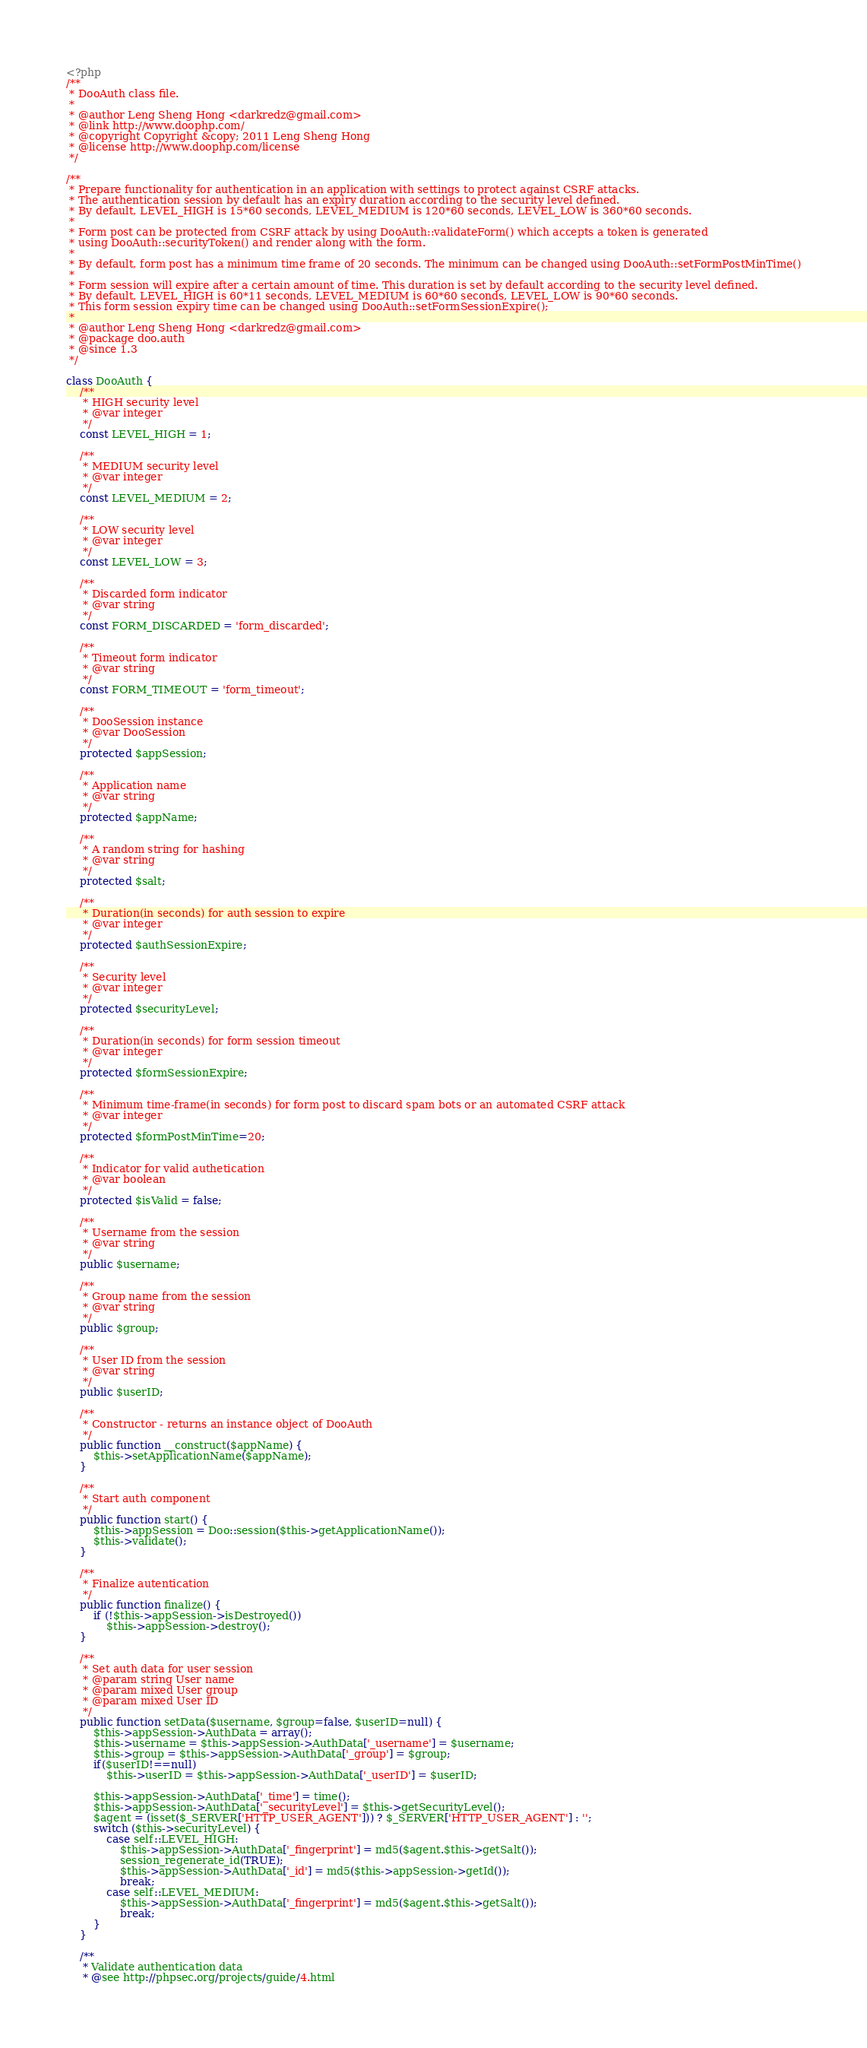Convert code to text. <code><loc_0><loc_0><loc_500><loc_500><_PHP_><?php
/**
 * DooAuth class file.
 *
 * @author Leng Sheng Hong <darkredz@gmail.com>
 * @link http://www.doophp.com/
 * @copyright Copyright &copy; 2011 Leng Sheng Hong
 * @license http://www.doophp.com/license
 */

/**
 * Prepare functionality for authentication in an application with settings to protect against CSRF attacks.
 * The authentication session by default has an expiry duration according to the security level defined.
 * By default, LEVEL_HIGH is 15*60 seconds, LEVEL_MEDIUM is 120*60 seconds, LEVEL_LOW is 360*60 seconds.
 *
 * Form post can be protected from CSRF attack by using DooAuth::validateForm() which accepts a token is generated
 * using DooAuth::securityToken() and render along with the form.
 *
 * By default, form post has a minimum time frame of 20 seconds. The minimum can be changed using DooAuth::setFormPostMinTime()
 *
 * Form session will expire after a certain amount of time. This duration is set by default according to the security level defined.
 * By default, LEVEL_HIGH is 60*11 seconds, LEVEL_MEDIUM is 60*60 seconds, LEVEL_LOW is 90*60 seconds.
 * This form session expiry time can be changed using DooAuth::setFormSessionExpire();
 *
 * @author Leng Sheng Hong <darkredz@gmail.com>
 * @package doo.auth
 * @since 1.3
 */

class DooAuth {
    /**
     * HIGH security level
     * @var integer
     */
    const LEVEL_HIGH = 1;

    /**
     * MEDIUM security level
     * @var integer
     */
    const LEVEL_MEDIUM = 2;

    /**
     * LOW security level
     * @var integer
     */
    const LEVEL_LOW = 3;

    /**
     * Discarded form indicator
     * @var string
     */
    const FORM_DISCARDED = 'form_discarded';

    /**
     * Timeout form indicator
     * @var string
     */
    const FORM_TIMEOUT = 'form_timeout';

    /**
     * DooSession instance
     * @var DooSession
     */
    protected $appSession;

    /**
     * Application name
     * @var string
     */
    protected $appName;

    /**
     * A random string for hashing
     * @var string
     */
    protected $salt;

    /**
     * Duration(in seconds) for auth session to expire
     * @var integer
     */
    protected $authSessionExpire;

    /**
     * Security level
     * @var integer
     */
    protected $securityLevel;

    /**
     * Duration(in seconds) for form session timeout
     * @var integer
     */
    protected $formSessionExpire;

    /**
     * Minimum time-frame(in seconds) for form post to discard spam bots or an automated CSRF attack
     * @var integer
     */
    protected $formPostMinTime=20;

    /**
     * Indicator for valid authetication
     * @var boolean
     */
    protected $isValid = false;

    /**
     * Username from the session
     * @var string
     */
    public $username;

    /**
     * Group name from the session
     * @var string
     */
    public $group;

    /**
     * User ID from the session
     * @var string
     */
    public $userID;

    /**
     * Constructor - returns an instance object of DooAuth
     */
    public function __construct($appName) {
        $this->setApplicationName($appName);
    }

    /**
     * Start auth component
     */
    public function start() {
        $this->appSession = Doo::session($this->getApplicationName());
        $this->validate();
    }

    /**
     * Finalize autentication
     */
    public function finalize() {
        if (!$this->appSession->isDestroyed())
            $this->appSession->destroy();
    }

    /**
     * Set auth data for user session
     * @param string User name
     * @param mixed User group
     * @param mixed User ID
     */
    public function setData($username, $group=false, $userID=null) {
        $this->appSession->AuthData = array();
        $this->username = $this->appSession->AuthData['_username'] = $username;
        $this->group = $this->appSession->AuthData['_group'] = $group;
		if($userID!==null)
			$this->userID = $this->appSession->AuthData['_userID'] = $userID;

        $this->appSession->AuthData['_time'] = time();
        $this->appSession->AuthData['_securityLevel'] = $this->getSecurityLevel();
        $agent = (isset($_SERVER['HTTP_USER_AGENT'])) ? $_SERVER['HTTP_USER_AGENT'] : '';
        switch ($this->securityLevel) {
            case self::LEVEL_HIGH:
                $this->appSession->AuthData['_fingerprint'] = md5($agent.$this->getSalt());
                session_regenerate_id(TRUE);
                $this->appSession->AuthData['_id'] = md5($this->appSession->getId());
                break;
            case self::LEVEL_MEDIUM:
                $this->appSession->AuthData['_fingerprint'] = md5($agent.$this->getSalt());
                break;
        }
    }

    /**
     * Validate authentication data
     * @see http://phpsec.org/projects/guide/4.html</code> 